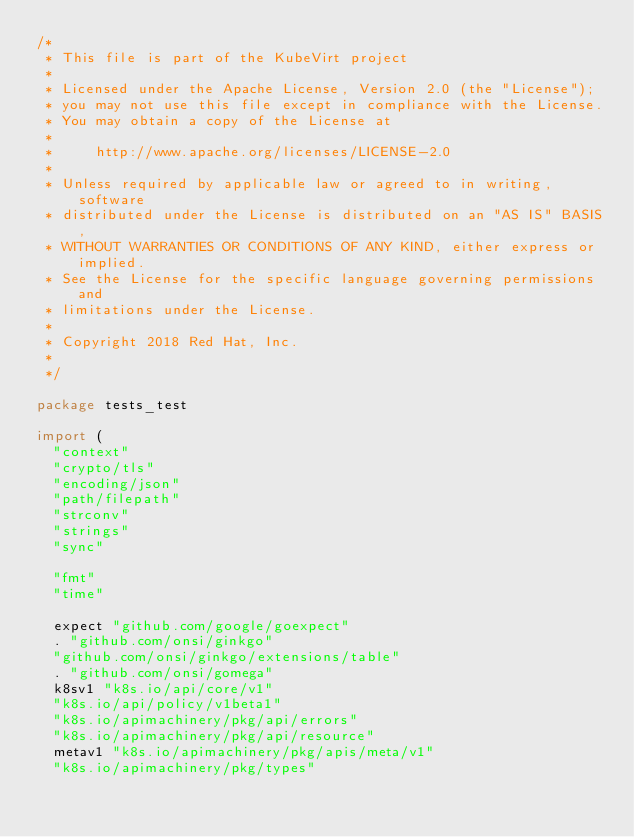Convert code to text. <code><loc_0><loc_0><loc_500><loc_500><_Go_>/*
 * This file is part of the KubeVirt project
 *
 * Licensed under the Apache License, Version 2.0 (the "License");
 * you may not use this file except in compliance with the License.
 * You may obtain a copy of the License at
 *
 *     http://www.apache.org/licenses/LICENSE-2.0
 *
 * Unless required by applicable law or agreed to in writing, software
 * distributed under the License is distributed on an "AS IS" BASIS,
 * WITHOUT WARRANTIES OR CONDITIONS OF ANY KIND, either express or implied.
 * See the License for the specific language governing permissions and
 * limitations under the License.
 *
 * Copyright 2018 Red Hat, Inc.
 *
 */

package tests_test

import (
	"context"
	"crypto/tls"
	"encoding/json"
	"path/filepath"
	"strconv"
	"strings"
	"sync"

	"fmt"
	"time"

	expect "github.com/google/goexpect"
	. "github.com/onsi/ginkgo"
	"github.com/onsi/ginkgo/extensions/table"
	. "github.com/onsi/gomega"
	k8sv1 "k8s.io/api/core/v1"
	"k8s.io/api/policy/v1beta1"
	"k8s.io/apimachinery/pkg/api/errors"
	"k8s.io/apimachinery/pkg/api/resource"
	metav1 "k8s.io/apimachinery/pkg/apis/meta/v1"
	"k8s.io/apimachinery/pkg/types"</code> 